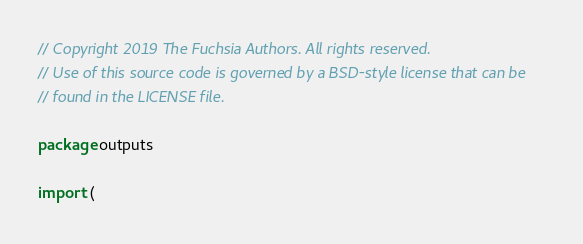<code> <loc_0><loc_0><loc_500><loc_500><_Go_>// Copyright 2019 The Fuchsia Authors. All rights reserved.
// Use of this source code is governed by a BSD-style license that can be
// found in the LICENSE file.

package outputs

import (</code> 